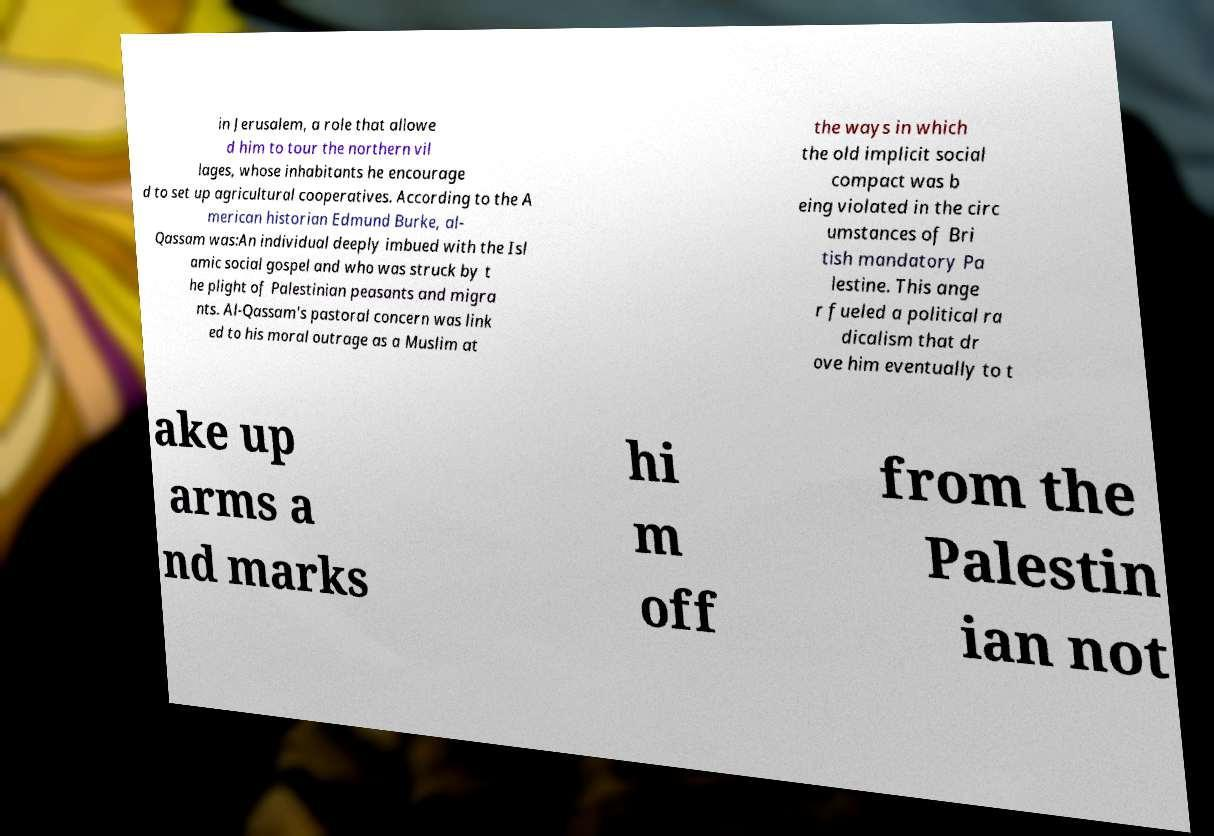Could you assist in decoding the text presented in this image and type it out clearly? in Jerusalem, a role that allowe d him to tour the northern vil lages, whose inhabitants he encourage d to set up agricultural cooperatives. According to the A merican historian Edmund Burke, al- Qassam was:An individual deeply imbued with the Isl amic social gospel and who was struck by t he plight of Palestinian peasants and migra nts. Al-Qassam's pastoral concern was link ed to his moral outrage as a Muslim at the ways in which the old implicit social compact was b eing violated in the circ umstances of Bri tish mandatory Pa lestine. This ange r fueled a political ra dicalism that dr ove him eventually to t ake up arms a nd marks hi m off from the Palestin ian not 